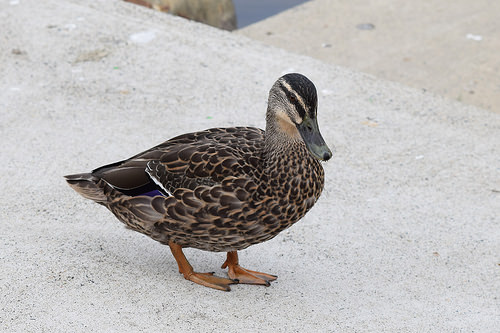<image>
Is there a duck on the pavement? Yes. Looking at the image, I can see the duck is positioned on top of the pavement, with the pavement providing support. 